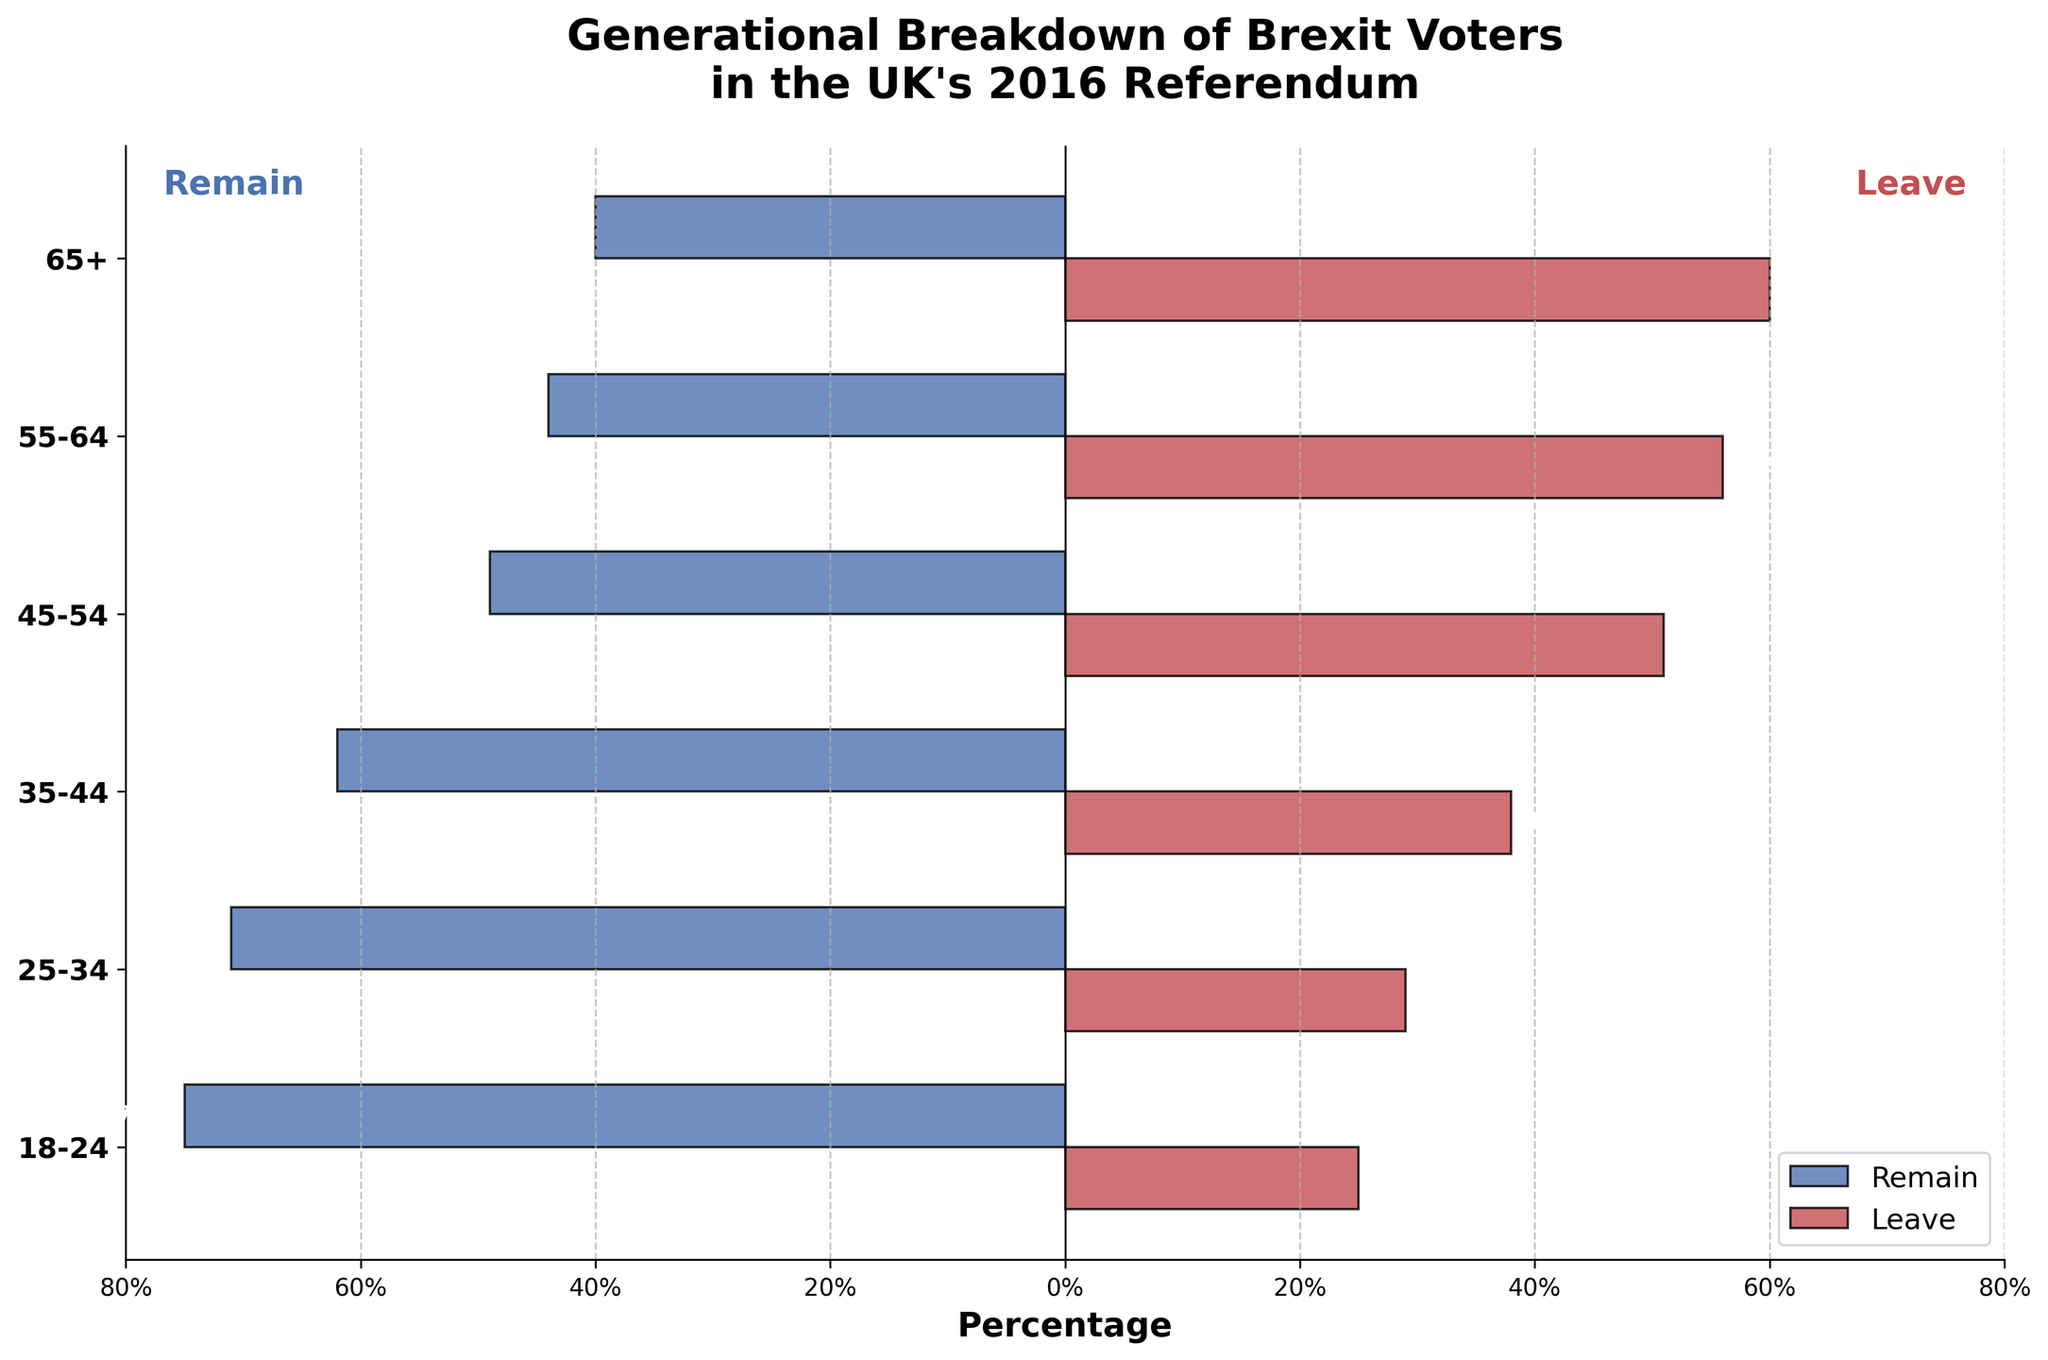What's the title of the figure? The title is located at the top of the figure in larger and bold text. It reads: "Generational Breakdown of Brexit Voters in the UK's 2016 Referendum."
Answer: Generational Breakdown of Brexit Voters in the UK's 2016 Referendum What does the x-axis represent? The x-axis is labeled with 'Percentage' indicating that it shows the percentage of voters. Values range from -80% to 80%, with negative percentages representing 'Remain' and positive percentages representing 'Leave.'
Answer: Percentage How do the percentages of 'Remain' and 'Leave' voters in the "18-24" age group compare? The bars for the "18-24" age group show that 75% voted to Remain and 25% voted to Leave.
Answer: Remain: 75%, Leave: 25% Which age group had the closest percentage split between 'Remain' and 'Leave' voters? By looking at the length of the bars, the "45-54" age group had the closest split with 49% Remain and 51% Leave.
Answer: 45-54 What is the difference in the percentage of 'Remain' votes between the "35-44" and "55-64" age groups? The "35-44" age group had 62% Remain whereas the "55-64" age group had 44% Remain. The difference between these values is 62% - 44% = 18%.
Answer: 18% Which two age groups show the greatest disparity between 'Remain' and 'Leave' percentages? The "18-24" and "65+" age groups show the largest disparity. The "18-24" age group has 75% Remain and 25% Leave (difference of 50%), and the "65+" age group has 40% Remain and 60% Leave (difference of 20%).
Answer: 18-24 and 65+ What overall pattern do you observe about the relationship between age and likelihood to vote 'Remain'? Younger age groups have higher percentages of 'Remain' voters, and this percentage declines progressively in older age groups.
Answer: Younger age groups tend to vote 'Remain' more Rank the age groups from highest to lowest percentage of 'Remain' votes. The percentages of 'Remain' votes are: "18-24" (75%), "25-34" (71%), "35-44" (62%), "45-54" (49%), "55-64" (44%), "65+" (40%). So the ranking is "18-24", "25-34", "35-44", "45-54", "55-64", "65+".
Answer: 18-24, 25-34, 35-44, 45-54, 55-64, 65+ What is the average percentage of 'Leave' voters across all age groups? The 'Leave' percentages for each age group are: 60%, 56%, 51%, 38%, 29%, 25%. Adding them up, 60 + 56 + 51 + 38 + 29 + 25 = 259. There are 6 age groups, so the average is 259 / 6 ≈ 43.17%.
Answer: 43.17% What can you infer about the voting behavior of the '55-64' age group based on the figure? The "55-64" age group has more people voting 'Leave' (56%) compared to 'Remain' (44%), indicating a tendency towards favoring Brexit.
Answer: More likely to vote 'Leave' 